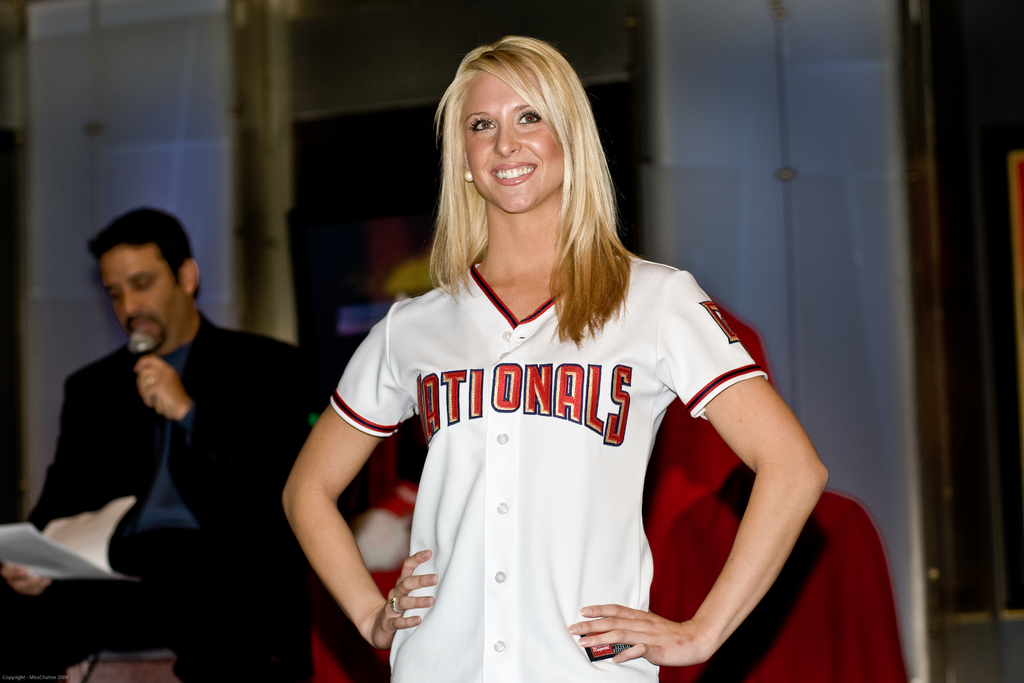What event might this woman be attending where she is modeling this jersey? She is likely at a sports-related promotional event, possibly a team unveiling or a fan meet-and-greet for the Washington Nationals. 